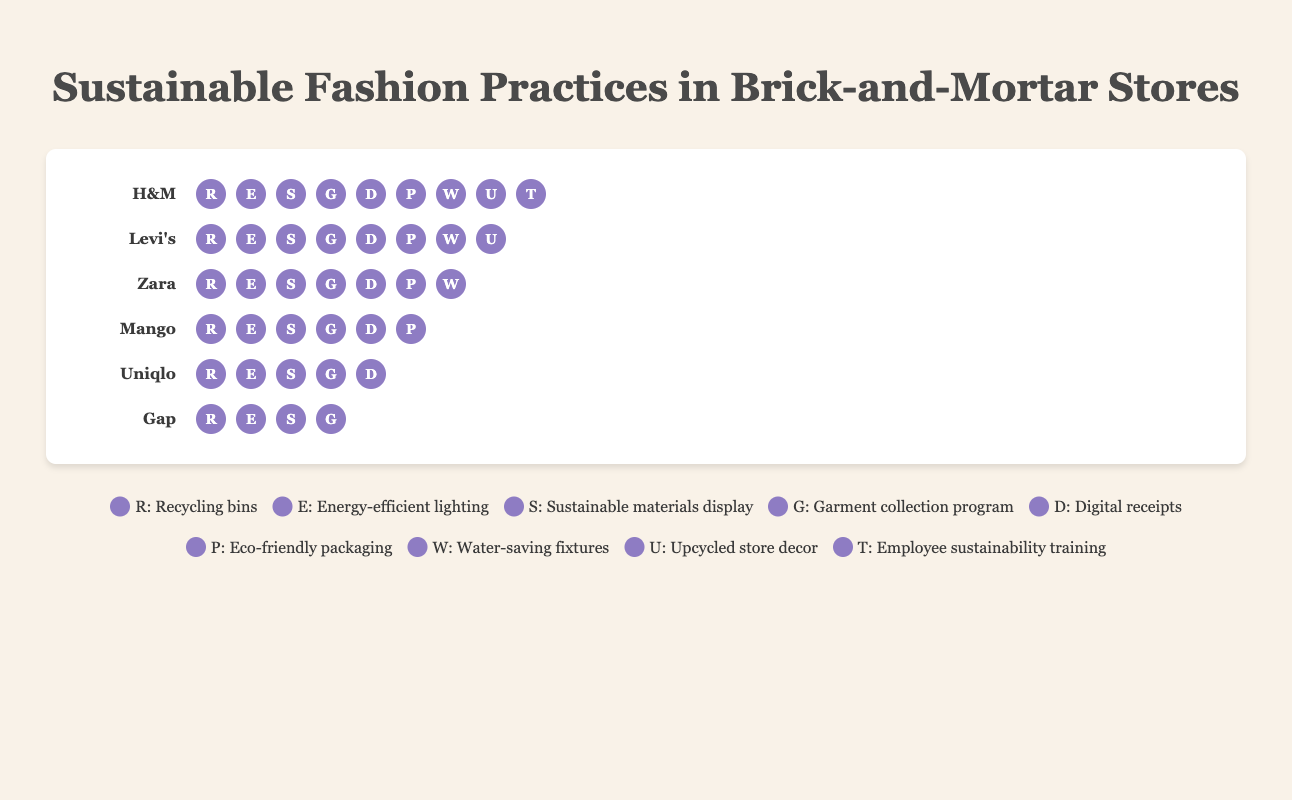What's the title of the figure? The title is usually found at the top of the figure and provides a summary of the content being displayed.
Answer: Sustainable Fashion Practices in Brick-and-Mortar Stores Which brand has the most sustainable practices? By counting the number of icons under each brand, we can see that H&M has the most icons, indicating nine sustainable practices.
Answer: H&M How many brands have adopted all nine listed practices? We need to count the number of brands that have all nine icons under their name. Only H&M has all nine practices listed.
Answer: One What's the least number of sustainable practices adopted by any brand? By counting the icons for each brand, we see Gap has the least number of practices, with only four icons displayed.
Answer: Four Which sustainable practice is common among all brands mentioned? By identifying the common icons under each brand's name, we find that the "Recycling bins" icon (R) appears under every brand.
Answer: Recycling bins (R) How many more sustainable practices does Levi's have compared to Uniqlo? Levi's has eight practices while Uniqlo has five. The difference can be calculated as 8 - 5.
Answer: Three Do all brands display the "Eco-friendly packaging" practice? By checking each brand's icons for the letter 'P', we find it is displayed by the brands H&M, Levi's, Zara, and Mango only.
Answer: No Which brand ranks just below H&M in terms of sustainable practices adopted? Counting the sustainable practices for each brand, Levi's is second with eight practices right below H&M.
Answer: Levi's What practice is denoted by the 'W' icon? The legend correlates each letter icon to a practice, showing that 'W' stands for Water-saving fixtures.
Answer: Water-saving fixtures How many practices are listed in the legend? Count the number of legend items provided at the end of the figure. Each practice corresponds to an icon.
Answer: Nine 